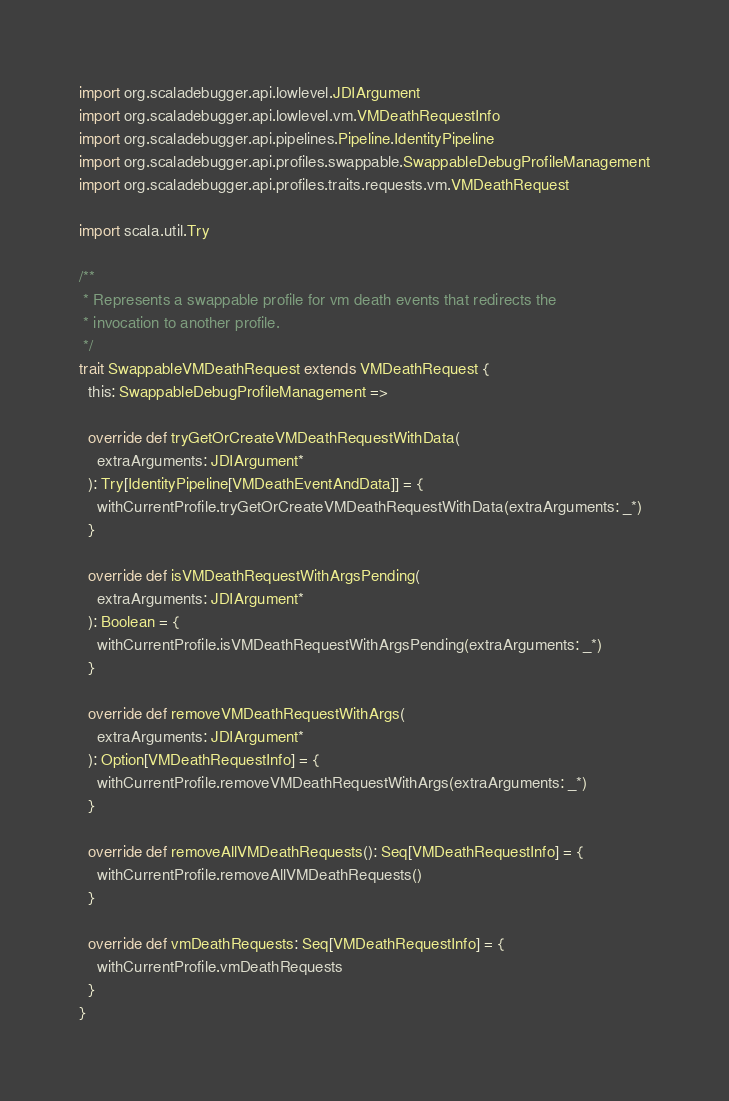Convert code to text. <code><loc_0><loc_0><loc_500><loc_500><_Scala_>
import org.scaladebugger.api.lowlevel.JDIArgument
import org.scaladebugger.api.lowlevel.vm.VMDeathRequestInfo
import org.scaladebugger.api.pipelines.Pipeline.IdentityPipeline
import org.scaladebugger.api.profiles.swappable.SwappableDebugProfileManagement
import org.scaladebugger.api.profiles.traits.requests.vm.VMDeathRequest

import scala.util.Try

/**
 * Represents a swappable profile for vm death events that redirects the
 * invocation to another profile.
 */
trait SwappableVMDeathRequest extends VMDeathRequest {
  this: SwappableDebugProfileManagement =>

  override def tryGetOrCreateVMDeathRequestWithData(
    extraArguments: JDIArgument*
  ): Try[IdentityPipeline[VMDeathEventAndData]] = {
    withCurrentProfile.tryGetOrCreateVMDeathRequestWithData(extraArguments: _*)
  }

  override def isVMDeathRequestWithArgsPending(
    extraArguments: JDIArgument*
  ): Boolean = {
    withCurrentProfile.isVMDeathRequestWithArgsPending(extraArguments: _*)
  }

  override def removeVMDeathRequestWithArgs(
    extraArguments: JDIArgument*
  ): Option[VMDeathRequestInfo] = {
    withCurrentProfile.removeVMDeathRequestWithArgs(extraArguments: _*)
  }

  override def removeAllVMDeathRequests(): Seq[VMDeathRequestInfo] = {
    withCurrentProfile.removeAllVMDeathRequests()
  }

  override def vmDeathRequests: Seq[VMDeathRequestInfo] = {
    withCurrentProfile.vmDeathRequests
  }
}
</code> 